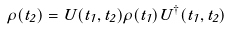<formula> <loc_0><loc_0><loc_500><loc_500>\rho ( t _ { 2 } ) = U ( t _ { 1 } , t _ { 2 } ) \rho ( t _ { 1 } ) U ^ { \dagger } ( t _ { 1 } , t _ { 2 } )</formula> 